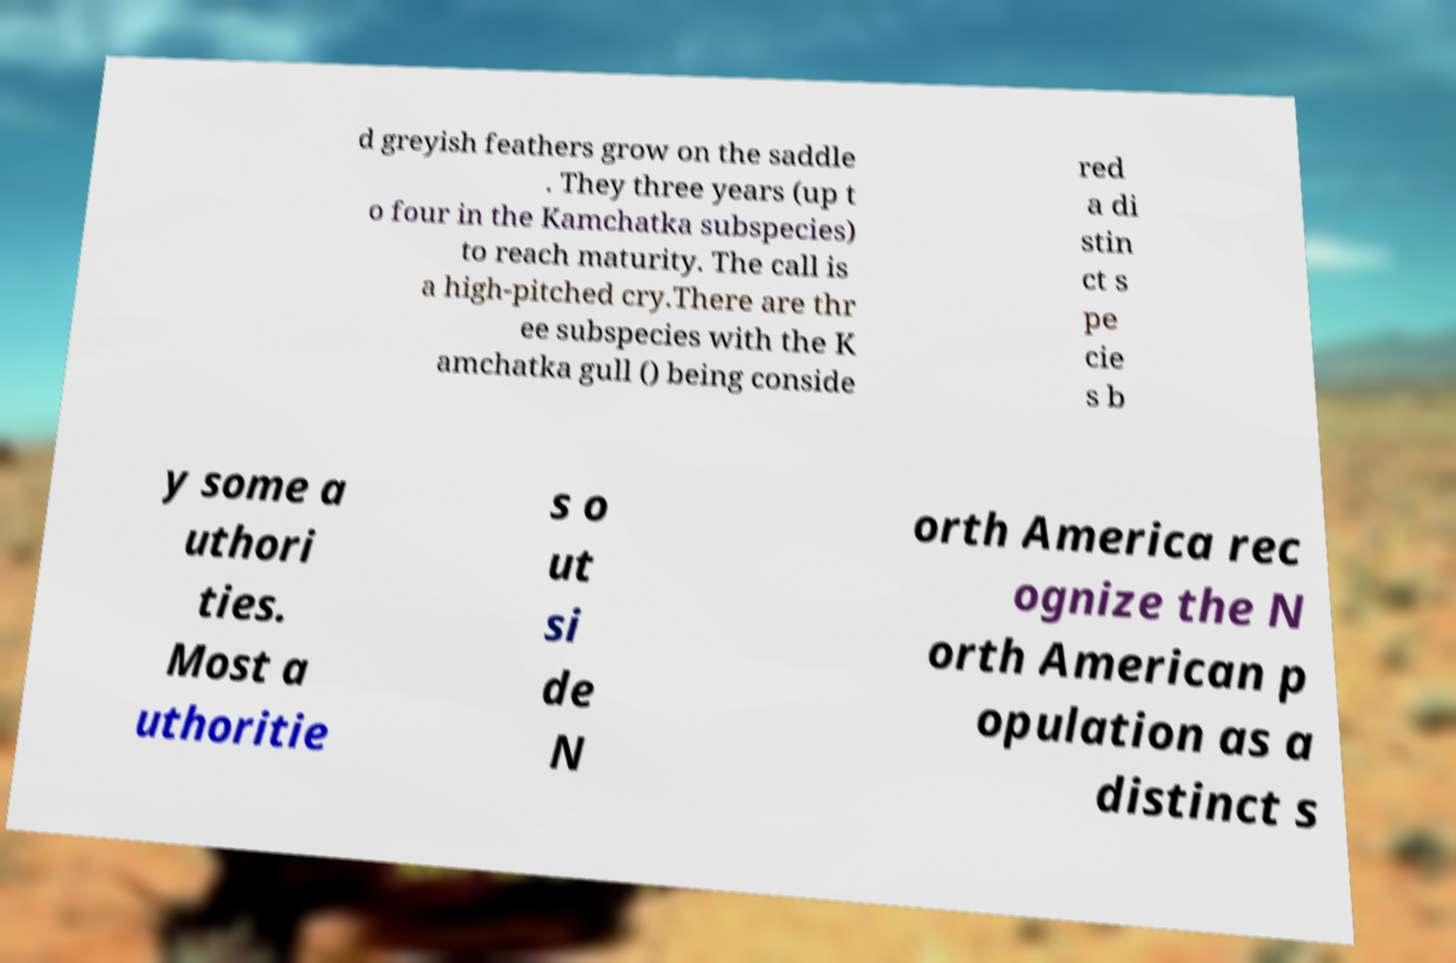I need the written content from this picture converted into text. Can you do that? d greyish feathers grow on the saddle . They three years (up t o four in the Kamchatka subspecies) to reach maturity. The call is a high-pitched cry.There are thr ee subspecies with the K amchatka gull () being conside red a di stin ct s pe cie s b y some a uthori ties. Most a uthoritie s o ut si de N orth America rec ognize the N orth American p opulation as a distinct s 